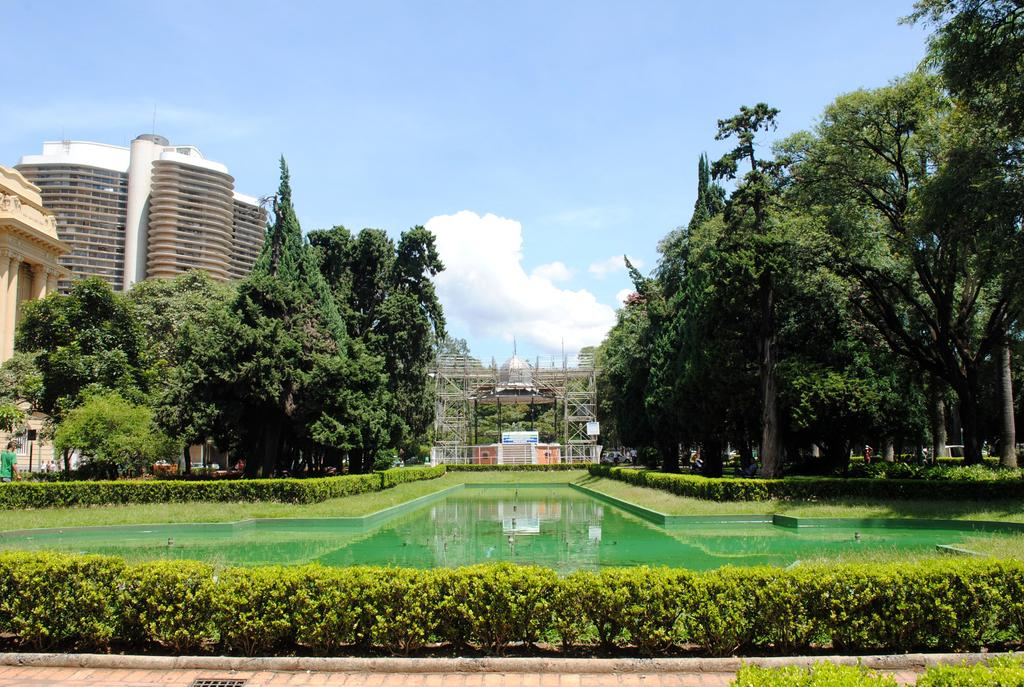What type of structures can be seen in the image? There are buildings in the image. What type of vegetation is present in the image? There are trees and plants in the image. What natural element is visible in the image? There is water visible in the image. What is the condition of the sky in the background? The sky in the background appears to be cloudy. What type of seed can be seen growing on the bridge in the image? There is no bridge or seed present in the image. 